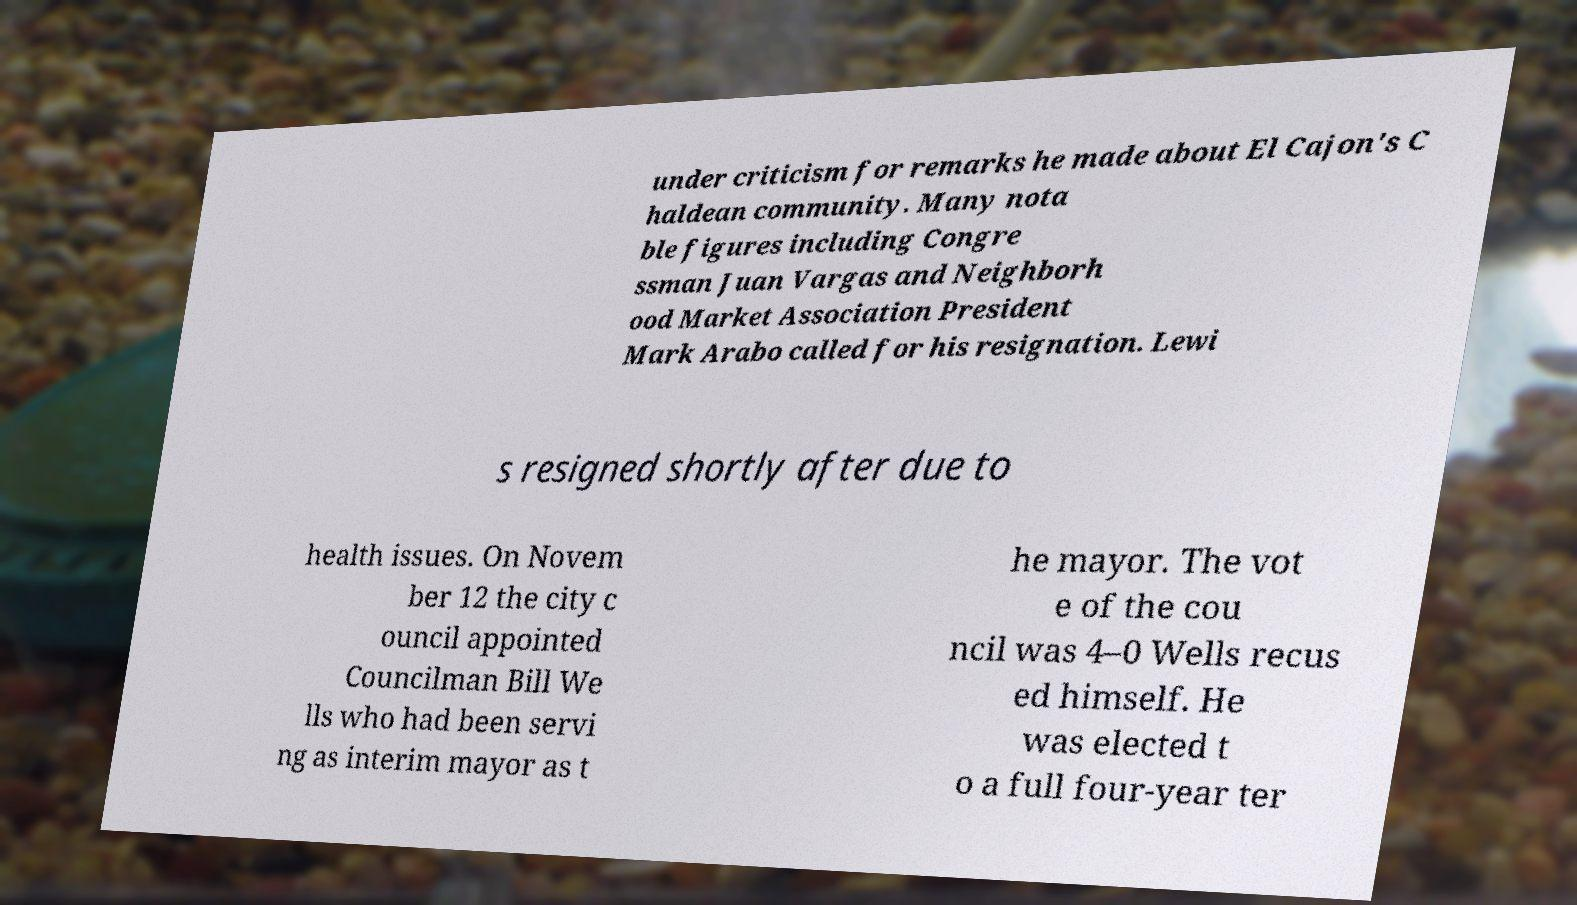Could you extract and type out the text from this image? under criticism for remarks he made about El Cajon's C haldean community. Many nota ble figures including Congre ssman Juan Vargas and Neighborh ood Market Association President Mark Arabo called for his resignation. Lewi s resigned shortly after due to health issues. On Novem ber 12 the city c ouncil appointed Councilman Bill We lls who had been servi ng as interim mayor as t he mayor. The vot e of the cou ncil was 4–0 Wells recus ed himself. He was elected t o a full four-year ter 